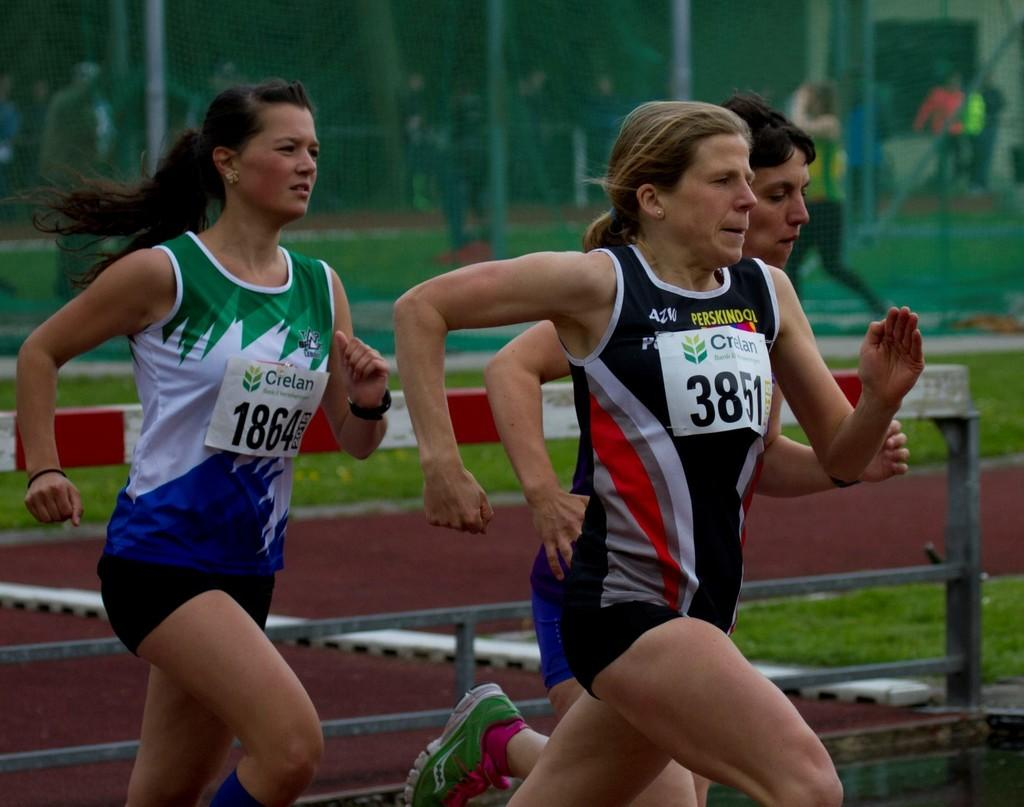<image>
Provide a brief description of the given image. A group of female runners with the one in the lead wearing number 3851. 